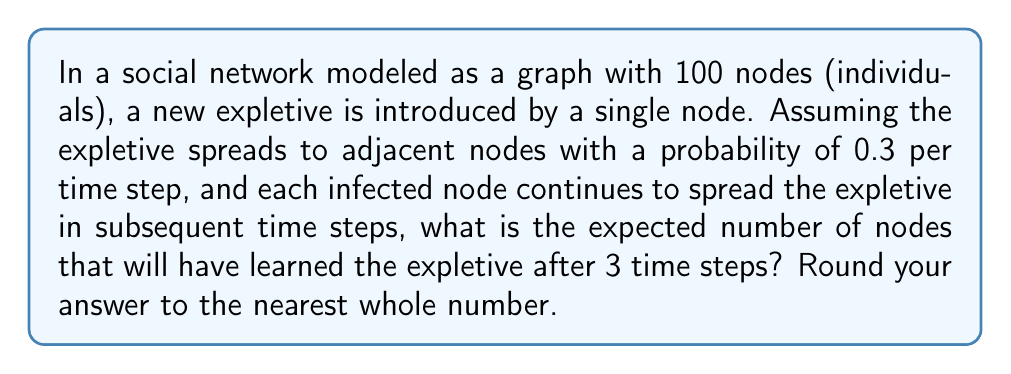Can you answer this question? Let's approach this step-by-step using concepts from graph theory and dynamical systems:

1) Initially, we have 1 infected node (the originator of the expletive).

2) Let's define $I_t$ as the number of infected nodes at time step $t$.

3) The expected number of new infections at each time step is:
   $E[\text{new infections}] = I_t \cdot 0.3 \cdot (100 - I_t)$

4) For the first time step (t=1):
   $E[I_1] = 1 + 1 \cdot 0.3 \cdot (100 - 1) = 30.7$

5) For the second time step (t=2):
   $E[I_2] = 30.7 + 30.7 \cdot 0.3 \cdot (100 - 30.7) = 30.7 + 641.931 = 672.631$

6) However, this exceeds the total number of nodes. We need to cap it at 100.
   So, $I_2 = 100$

7) For the third time step (t=3), all nodes are already infected, so $I_3 = 100$

8) Therefore, after 3 time steps, we expect all 100 nodes to have learned the expletive.

This model demonstrates the rapid spread of linguistic innovations in densely connected social networks, which is particularly relevant to the spread of expletives due to their often viral nature in social contexts.
Answer: 100 